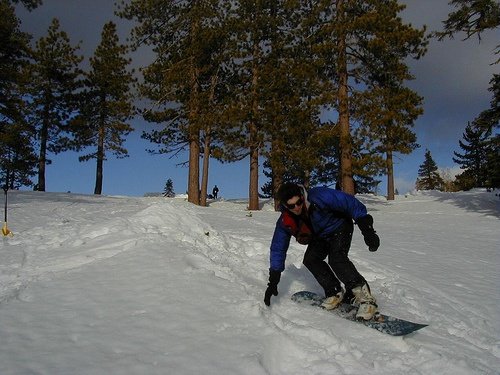Describe the objects in this image and their specific colors. I can see people in black, navy, gray, and maroon tones, snowboard in black, gray, and purple tones, and people in black and gray tones in this image. 